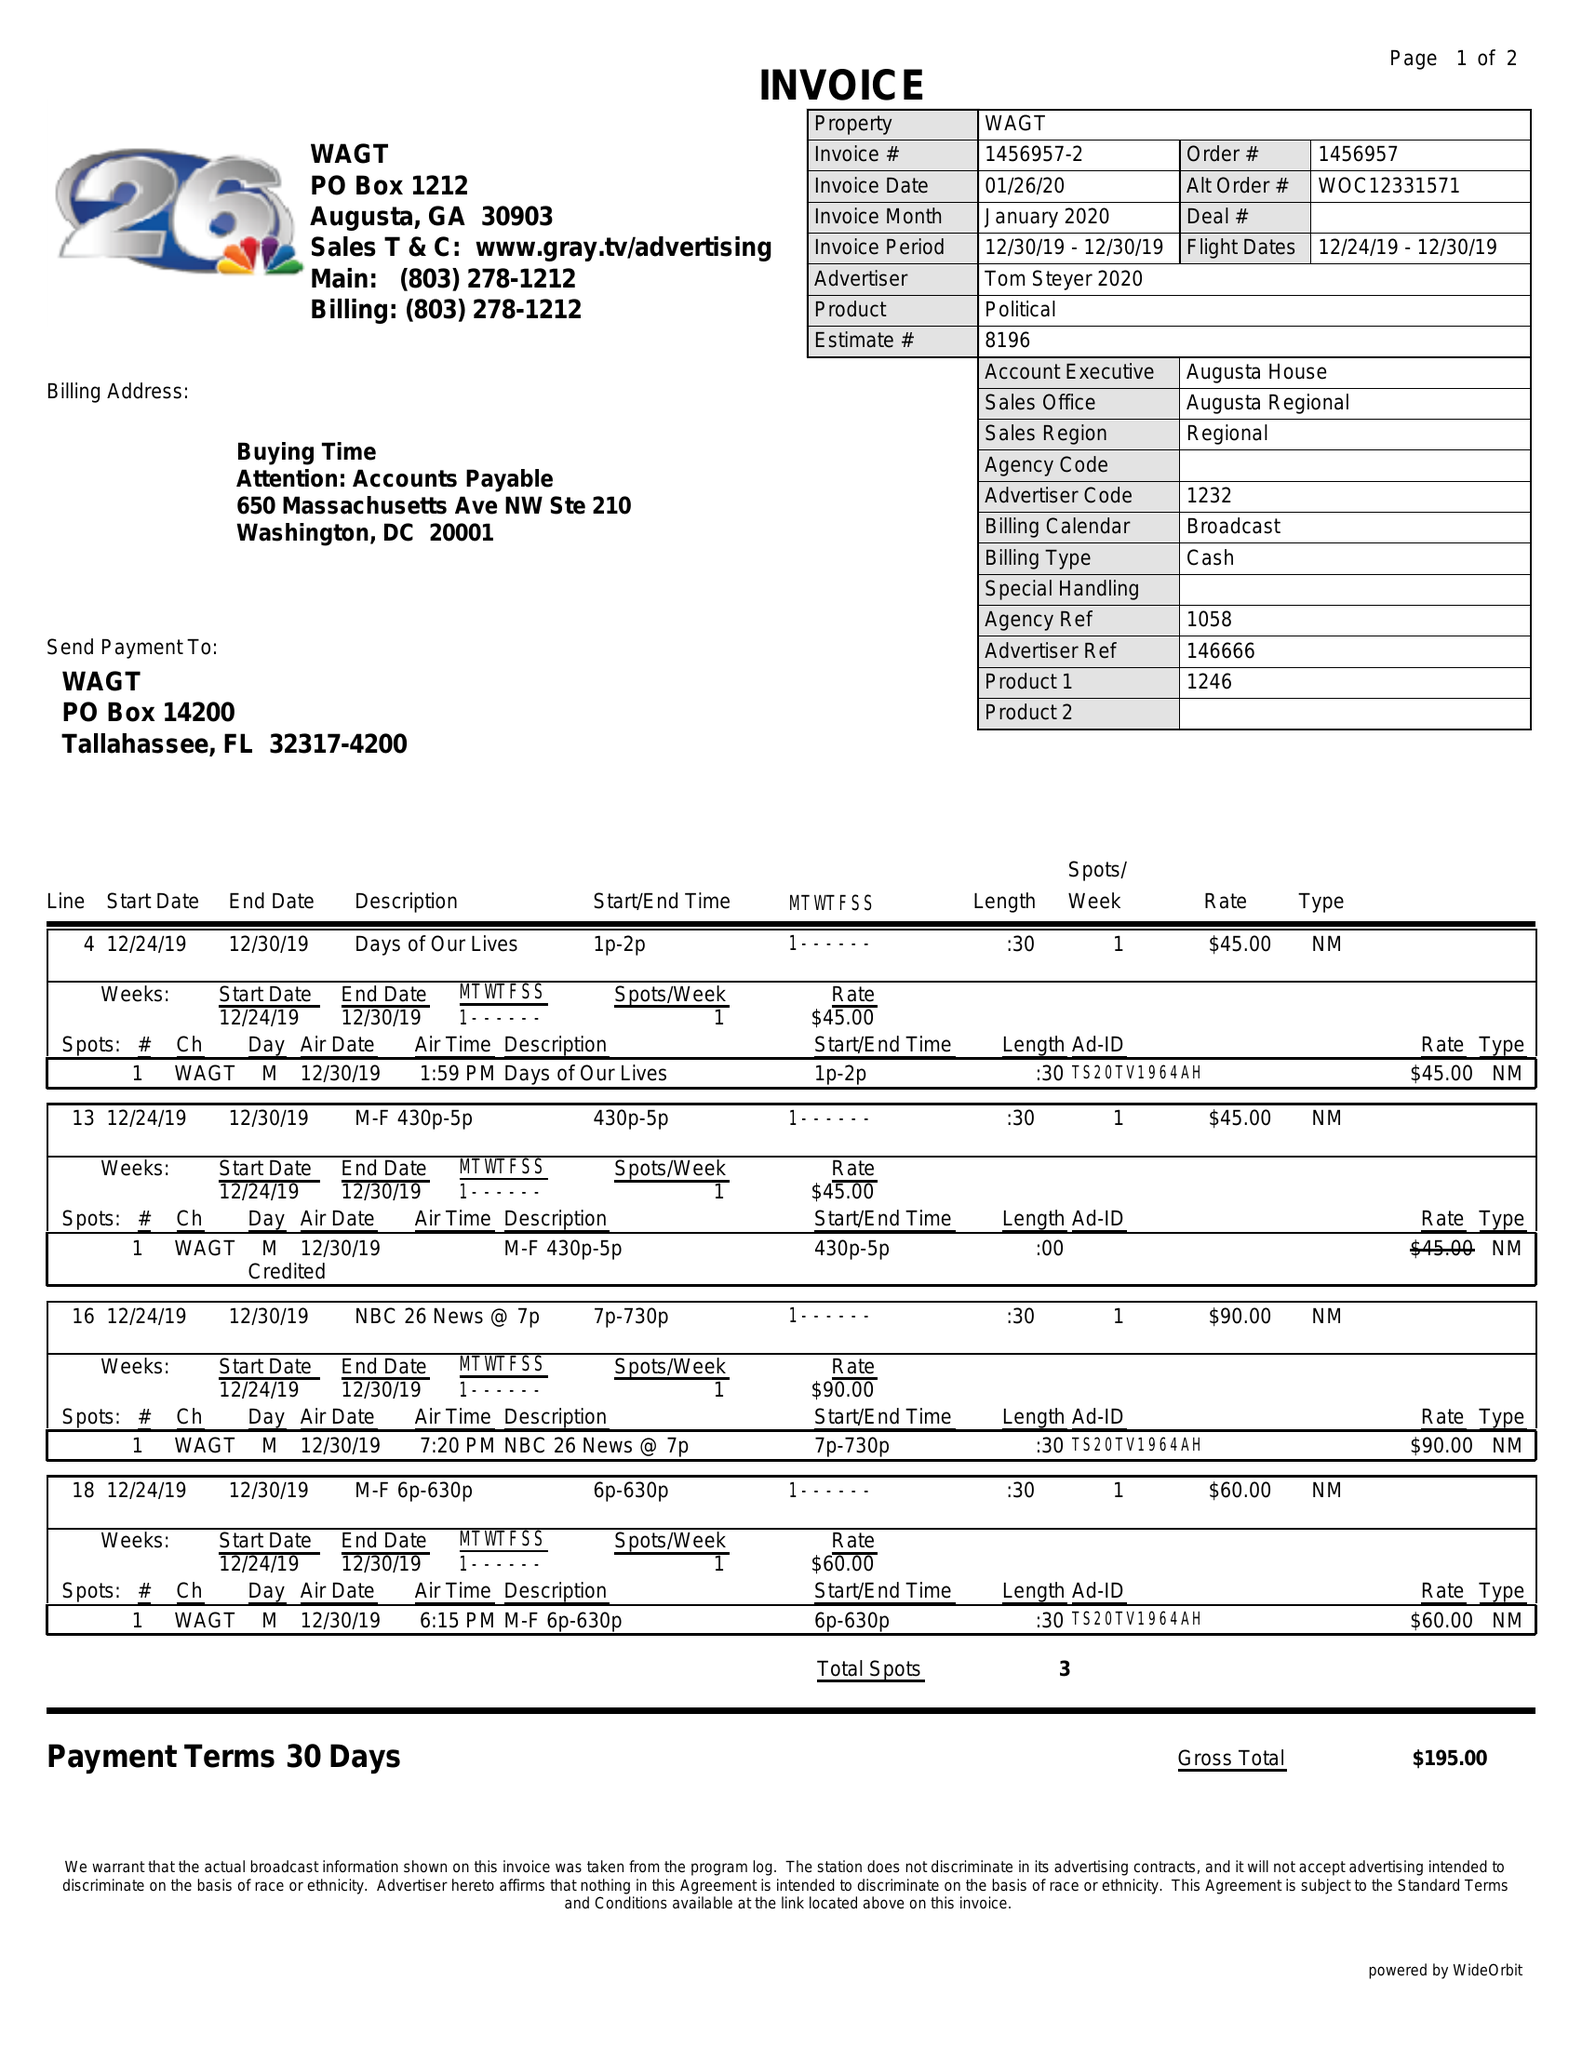What is the value for the flight_to?
Answer the question using a single word or phrase. 12/30/19 